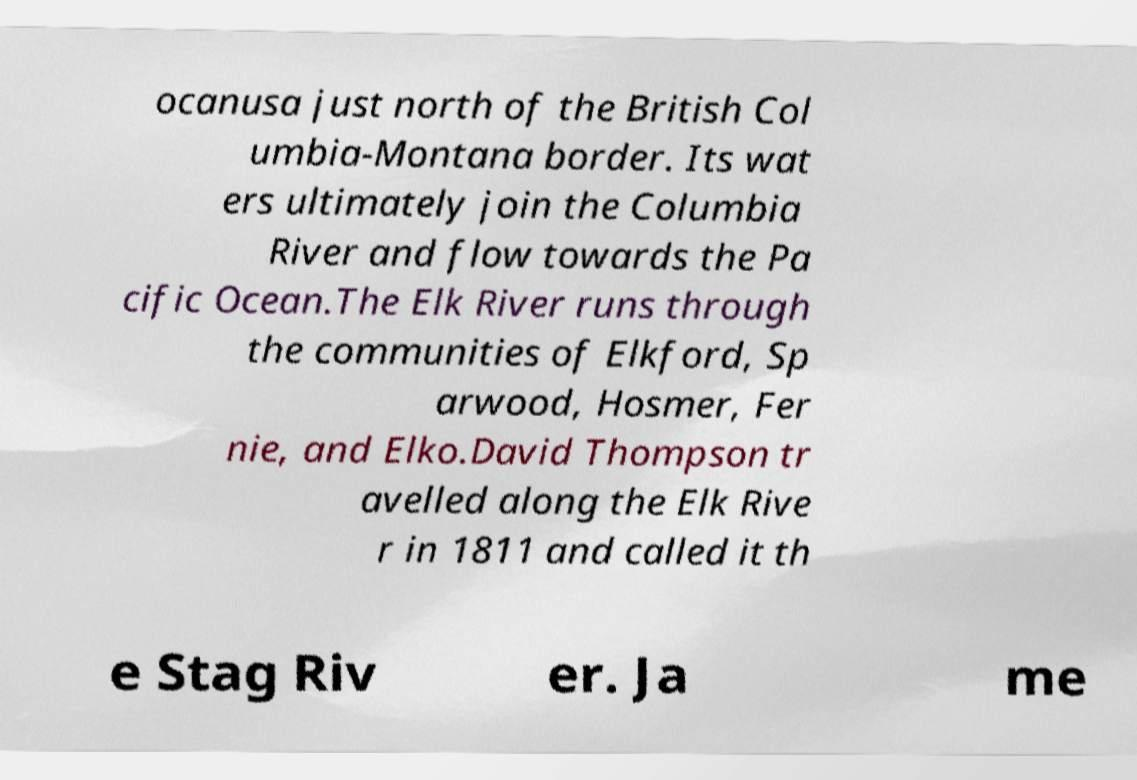Please read and relay the text visible in this image. What does it say? ocanusa just north of the British Col umbia-Montana border. Its wat ers ultimately join the Columbia River and flow towards the Pa cific Ocean.The Elk River runs through the communities of Elkford, Sp arwood, Hosmer, Fer nie, and Elko.David Thompson tr avelled along the Elk Rive r in 1811 and called it th e Stag Riv er. Ja me 